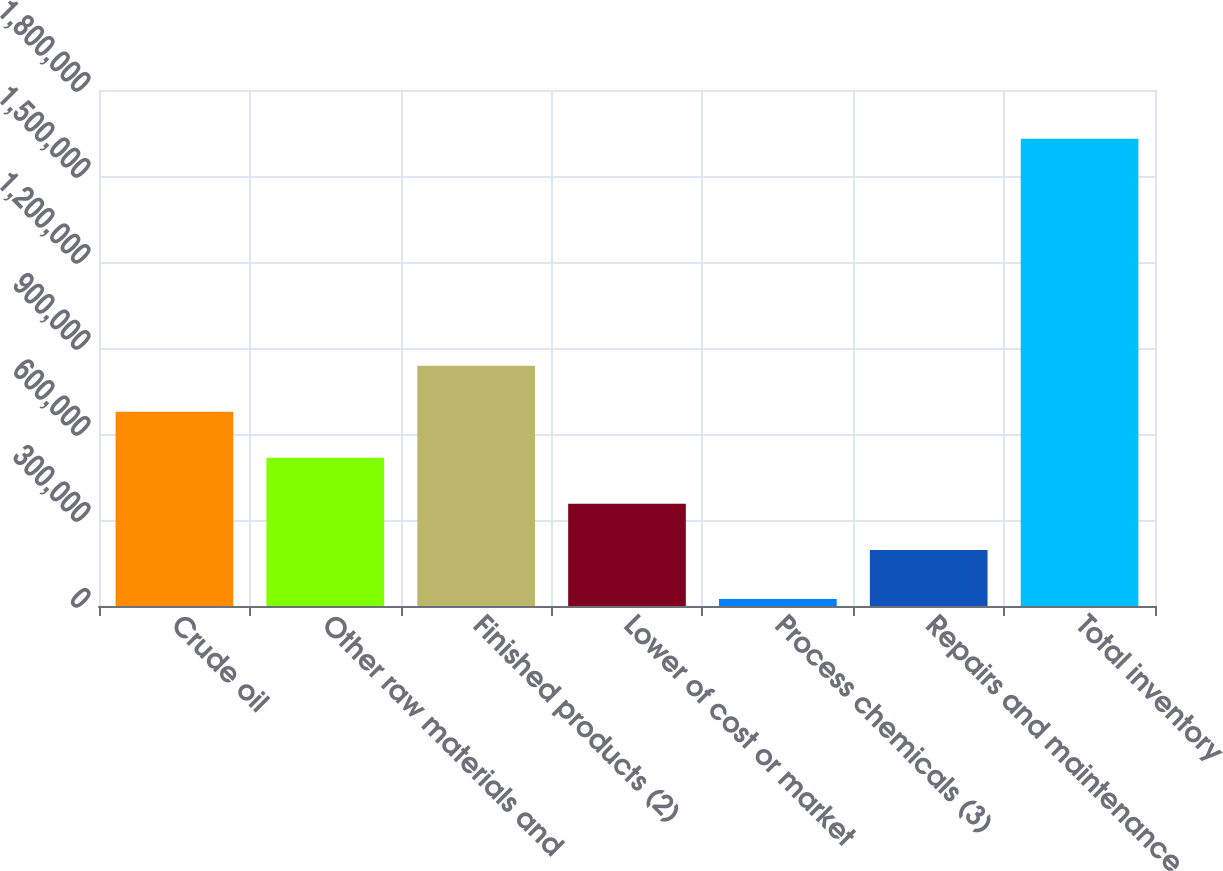Convert chart to OTSL. <chart><loc_0><loc_0><loc_500><loc_500><bar_chart><fcel>Crude oil<fcel>Other raw materials and<fcel>Finished products (2)<fcel>Lower of cost or market<fcel>Process chemicals (3)<fcel>Repairs and maintenance<fcel>Total inventory<nl><fcel>677352<fcel>516822<fcel>837882<fcel>356292<fcel>24792<fcel>195762<fcel>1.63009e+06<nl></chart> 